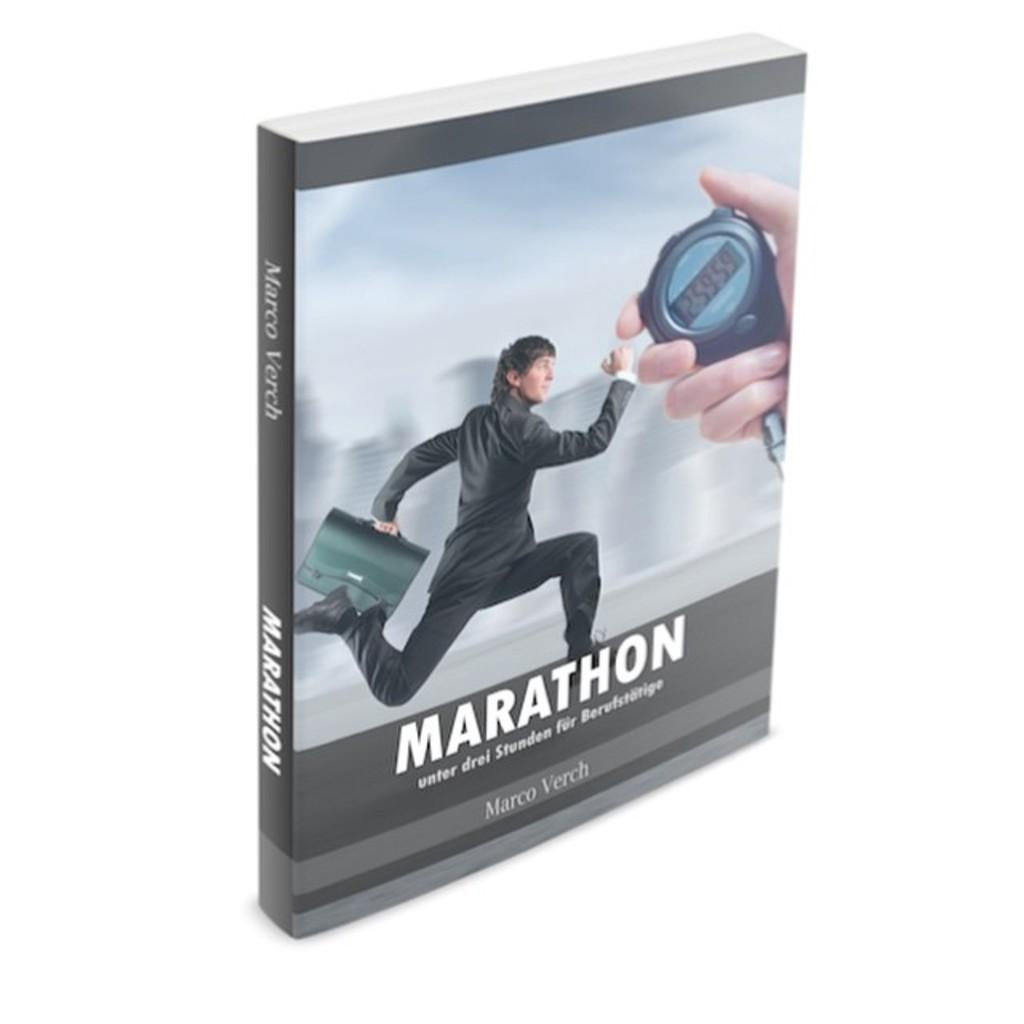What is the name of the book?
Give a very brief answer. Marathon. Name the author?
Your answer should be very brief. Marco verch. 